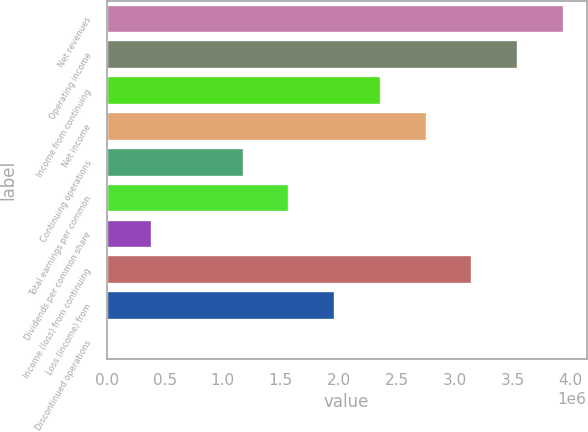Convert chart. <chart><loc_0><loc_0><loc_500><loc_500><bar_chart><fcel>Net revenues<fcel>Operating income<fcel>Income from continuing<fcel>Net income<fcel>Continuing operations<fcel>Total earnings per common<fcel>Dividends per common share<fcel>Income (loss) from continuing<fcel>Loss (income) from<fcel>Discontinued operations<nl><fcel>3.94016e+06<fcel>3.54614e+06<fcel>2.3641e+06<fcel>2.75811e+06<fcel>1.18205e+06<fcel>1.57606e+06<fcel>394016<fcel>3.15213e+06<fcel>1.97008e+06<fcel>0.22<nl></chart> 